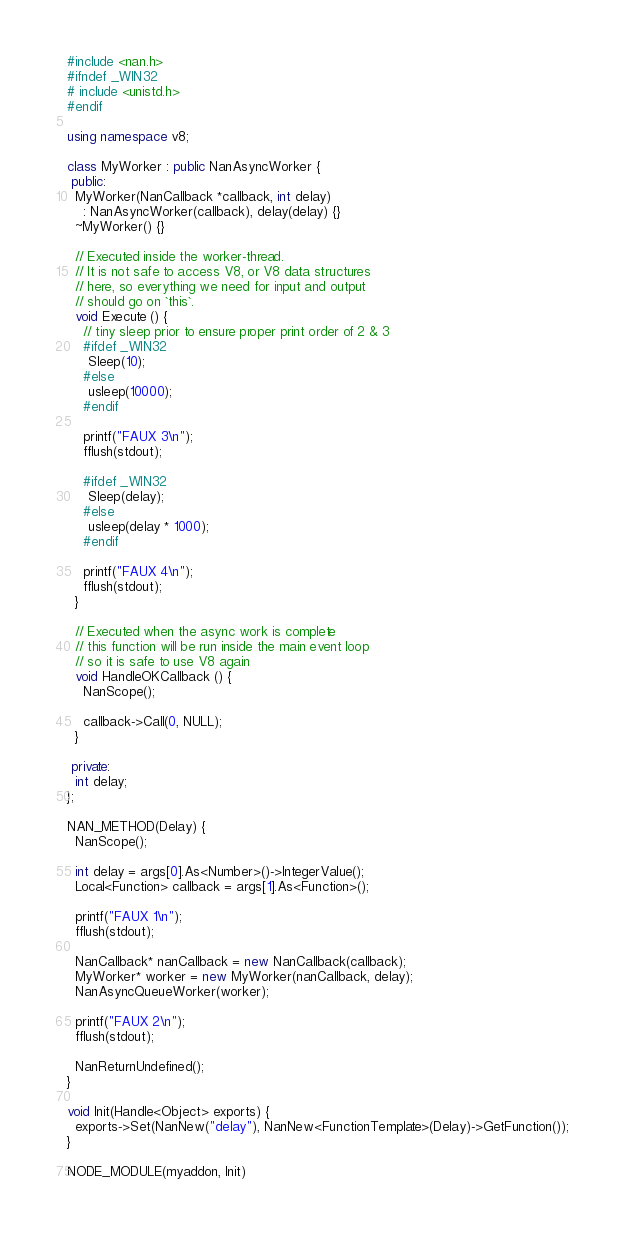Convert code to text. <code><loc_0><loc_0><loc_500><loc_500><_C++_>#include <nan.h>
#ifndef _WIN32
# include <unistd.h>
#endif

using namespace v8;

class MyWorker : public NanAsyncWorker {
 public:
  MyWorker(NanCallback *callback, int delay)
    : NanAsyncWorker(callback), delay(delay) {}
  ~MyWorker() {}

  // Executed inside the worker-thread.
  // It is not safe to access V8, or V8 data structures
  // here, so everything we need for input and output
  // should go on `this`.
  void Execute () {
    // tiny sleep prior to ensure proper print order of 2 & 3
    #ifdef _WIN32
     Sleep(10);
    #else
     usleep(10000);
    #endif

    printf("FAUX 3\n");
    fflush(stdout);

    #ifdef _WIN32
     Sleep(delay);
    #else
     usleep(delay * 1000);
    #endif

    printf("FAUX 4\n");
    fflush(stdout);
  }

  // Executed when the async work is complete
  // this function will be run inside the main event loop
  // so it is safe to use V8 again
  void HandleOKCallback () {
    NanScope();

    callback->Call(0, NULL);
  }

 private:
  int delay;
};

NAN_METHOD(Delay) {
  NanScope();

  int delay = args[0].As<Number>()->IntegerValue();
  Local<Function> callback = args[1].As<Function>();

  printf("FAUX 1\n");
  fflush(stdout);

  NanCallback* nanCallback = new NanCallback(callback);
  MyWorker* worker = new MyWorker(nanCallback, delay);
  NanAsyncQueueWorker(worker);

  printf("FAUX 2\n");
  fflush(stdout);

  NanReturnUndefined();
}

void Init(Handle<Object> exports) {
  exports->Set(NanNew("delay"), NanNew<FunctionTemplate>(Delay)->GetFunction());
}

NODE_MODULE(myaddon, Init)
</code> 